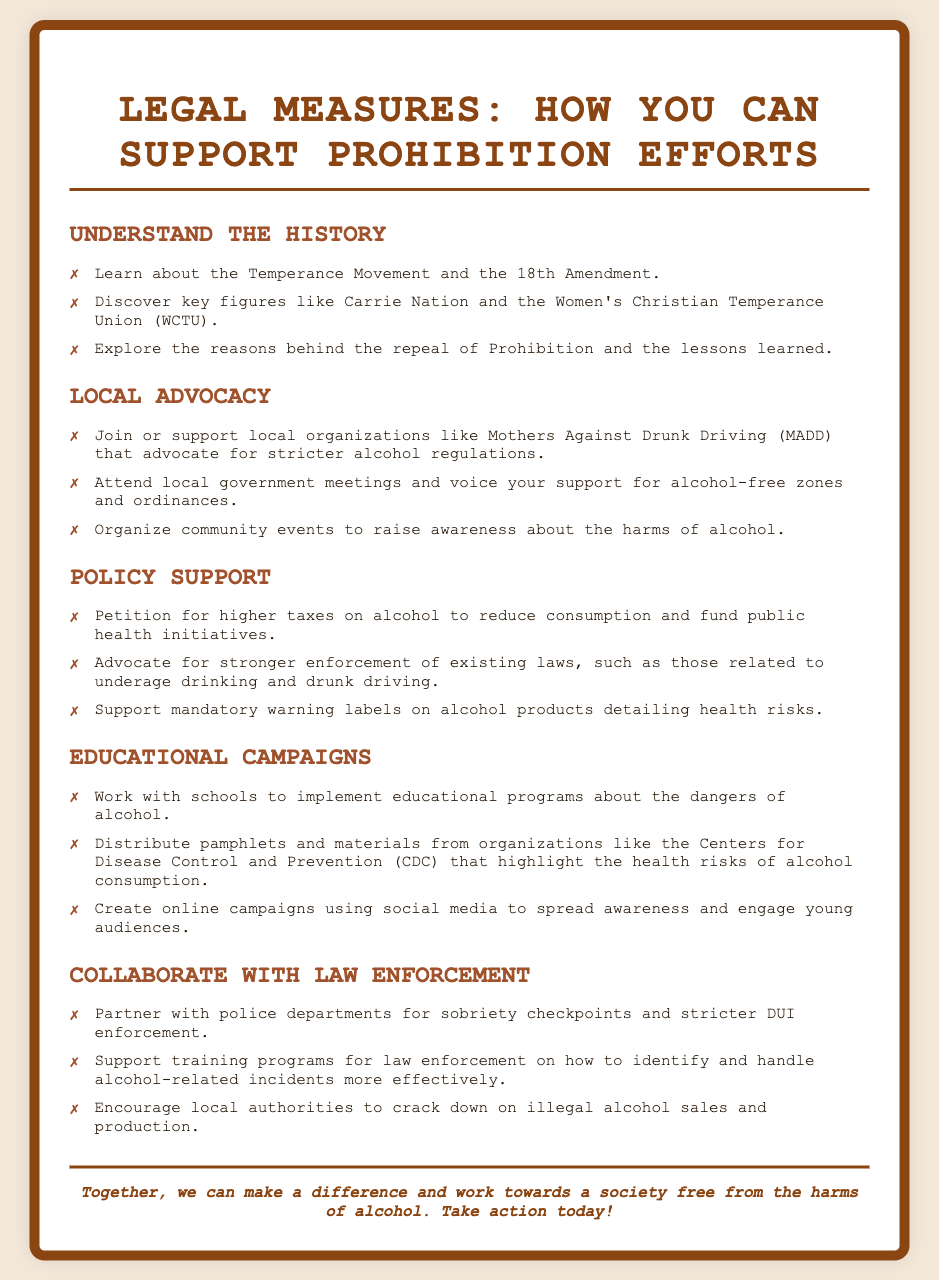what is the title of the poster? The title of the poster is centered at the top, indicating the main theme.
Answer: Legal Measures: How You Can Support Prohibition Efforts who was a key figure in the Temperance Movement? The document mentions specific individuals pivotal to the movement.
Answer: Carrie Nation which organization advocates for stricter alcohol regulations? The document lists various organizations involved in advocacy for prohibition efforts.
Answer: Mothers Against Drunk Driving what is one way to support local advocacy? The document provides examples of actions that can be taken to support local prohibition efforts.
Answer: Organize community events which health organization can be collaborated with for educational materials? The poster suggests collaborating with a notable public health organization for materials.
Answer: Centers for Disease Control and Prevention how can you promote awareness about alcohol dangers online? The document offers insights into how campaigns can be conducted to raise awareness on the dangers of alcohol.
Answer: Create online campaigns using social media what type of community events can help prohibition efforts? The document provides actionable suggestions for activities that promote awareness of the harms of alcohol.
Answer: Community events to raise awareness what type of checkpoints can be partnered with police departments? The document discusses a specific type of enforcement collaboration that can be increased to support prohibition efforts.
Answer: Sobriety checkpoints 